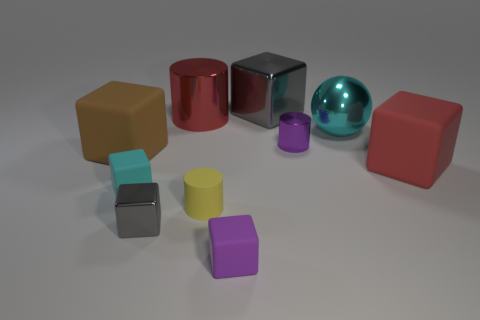There is a metallic thing that is in front of the tiny matte cube that is on the left side of the gray shiny block in front of the brown rubber cube; what shape is it?
Keep it short and to the point. Cube. Is there any other thing that is the same shape as the tiny cyan matte object?
Make the answer very short. Yes. How many blocks are gray objects or small purple matte objects?
Your answer should be compact. 3. There is a big matte thing that is to the right of the brown rubber cube; is it the same color as the big metallic cylinder?
Offer a terse response. Yes. What material is the large red thing that is on the right side of the gray metallic thing that is behind the gray object that is in front of the cyan rubber object?
Give a very brief answer. Rubber. Does the cyan block have the same size as the red rubber block?
Provide a succinct answer. No. Does the big shiny ball have the same color as the tiny rubber block on the left side of the small purple rubber cube?
Your answer should be compact. Yes. The big brown thing that is made of the same material as the yellow object is what shape?
Your response must be concise. Cube. Does the shiny thing in front of the brown thing have the same shape as the big cyan object?
Your answer should be very brief. No. What size is the matte thing that is on the right side of the small matte cube that is to the right of the tiny gray cube?
Provide a short and direct response. Large. 